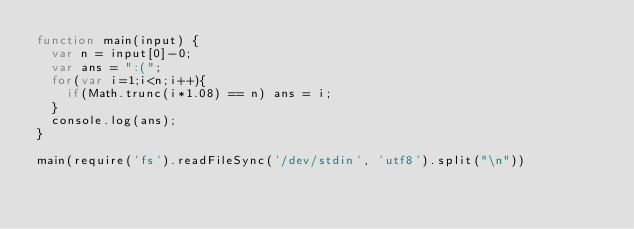<code> <loc_0><loc_0><loc_500><loc_500><_JavaScript_>function main(input) {
  var n = input[0]-0;
  var ans = ":(";
  for(var i=1;i<n;i++){
    if(Math.trunc(i*1.08) == n) ans = i;
  }
  console.log(ans);
}

main(require('fs').readFileSync('/dev/stdin', 'utf8').split("\n"))
</code> 